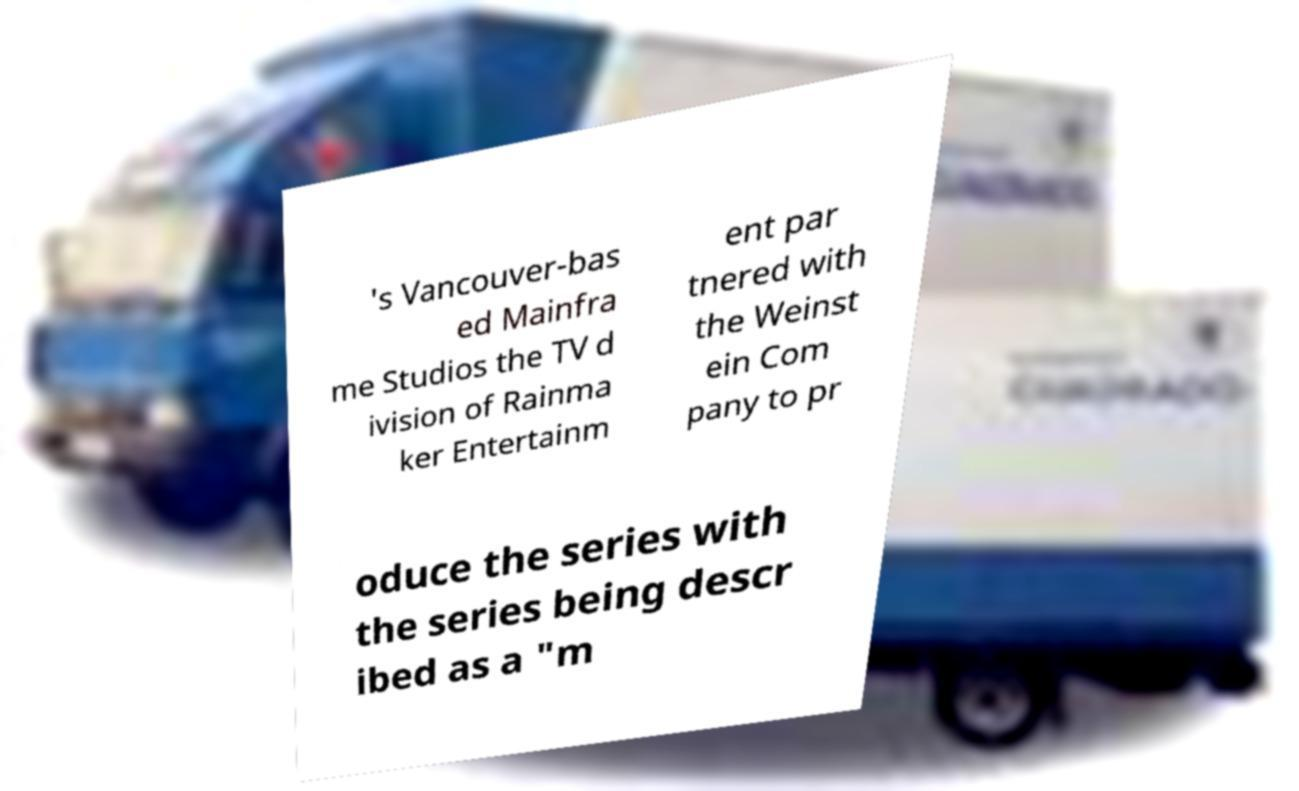I need the written content from this picture converted into text. Can you do that? 's Vancouver-bas ed Mainfra me Studios the TV d ivision of Rainma ker Entertainm ent par tnered with the Weinst ein Com pany to pr oduce the series with the series being descr ibed as a "m 